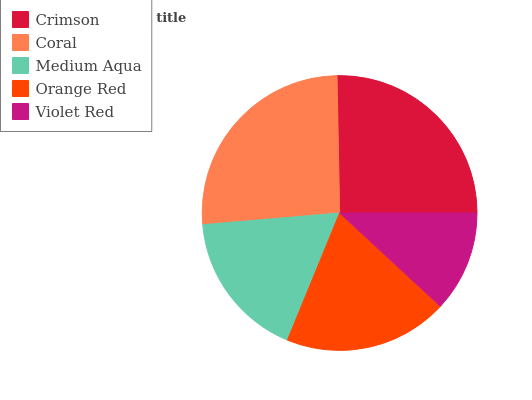Is Violet Red the minimum?
Answer yes or no. Yes. Is Coral the maximum?
Answer yes or no. Yes. Is Medium Aqua the minimum?
Answer yes or no. No. Is Medium Aqua the maximum?
Answer yes or no. No. Is Coral greater than Medium Aqua?
Answer yes or no. Yes. Is Medium Aqua less than Coral?
Answer yes or no. Yes. Is Medium Aqua greater than Coral?
Answer yes or no. No. Is Coral less than Medium Aqua?
Answer yes or no. No. Is Orange Red the high median?
Answer yes or no. Yes. Is Orange Red the low median?
Answer yes or no. Yes. Is Crimson the high median?
Answer yes or no. No. Is Violet Red the low median?
Answer yes or no. No. 